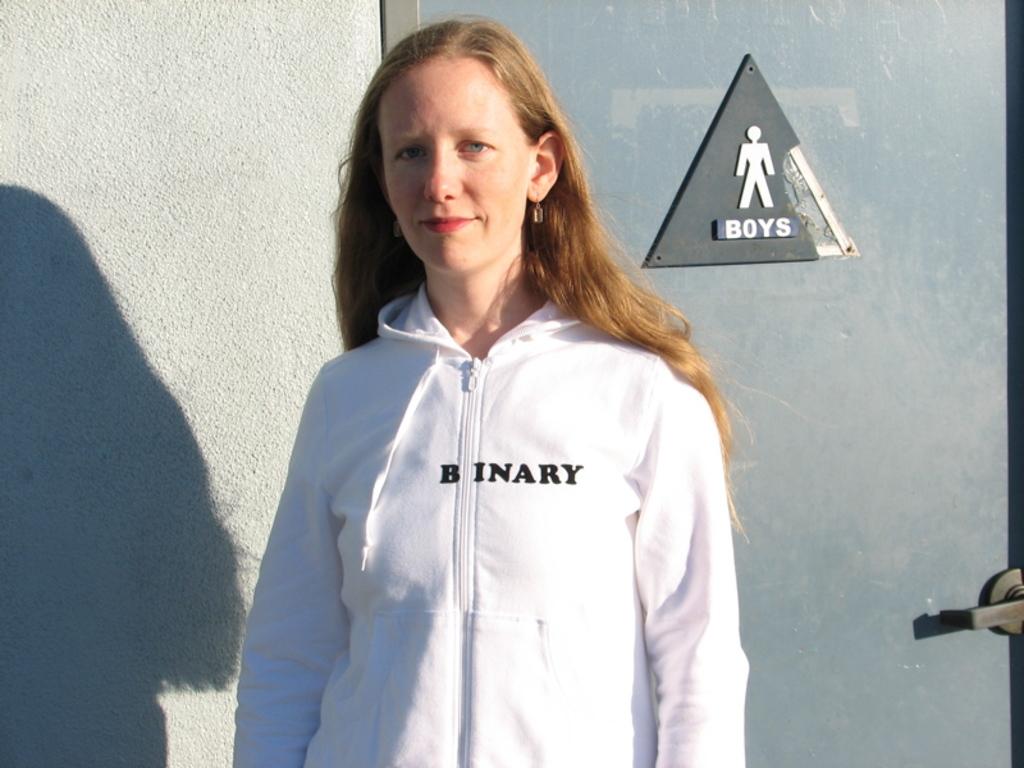Who's bathroom is behind the lady?
Give a very brief answer. Boys. What does her sweatshirt say?
Give a very brief answer. Binary. 